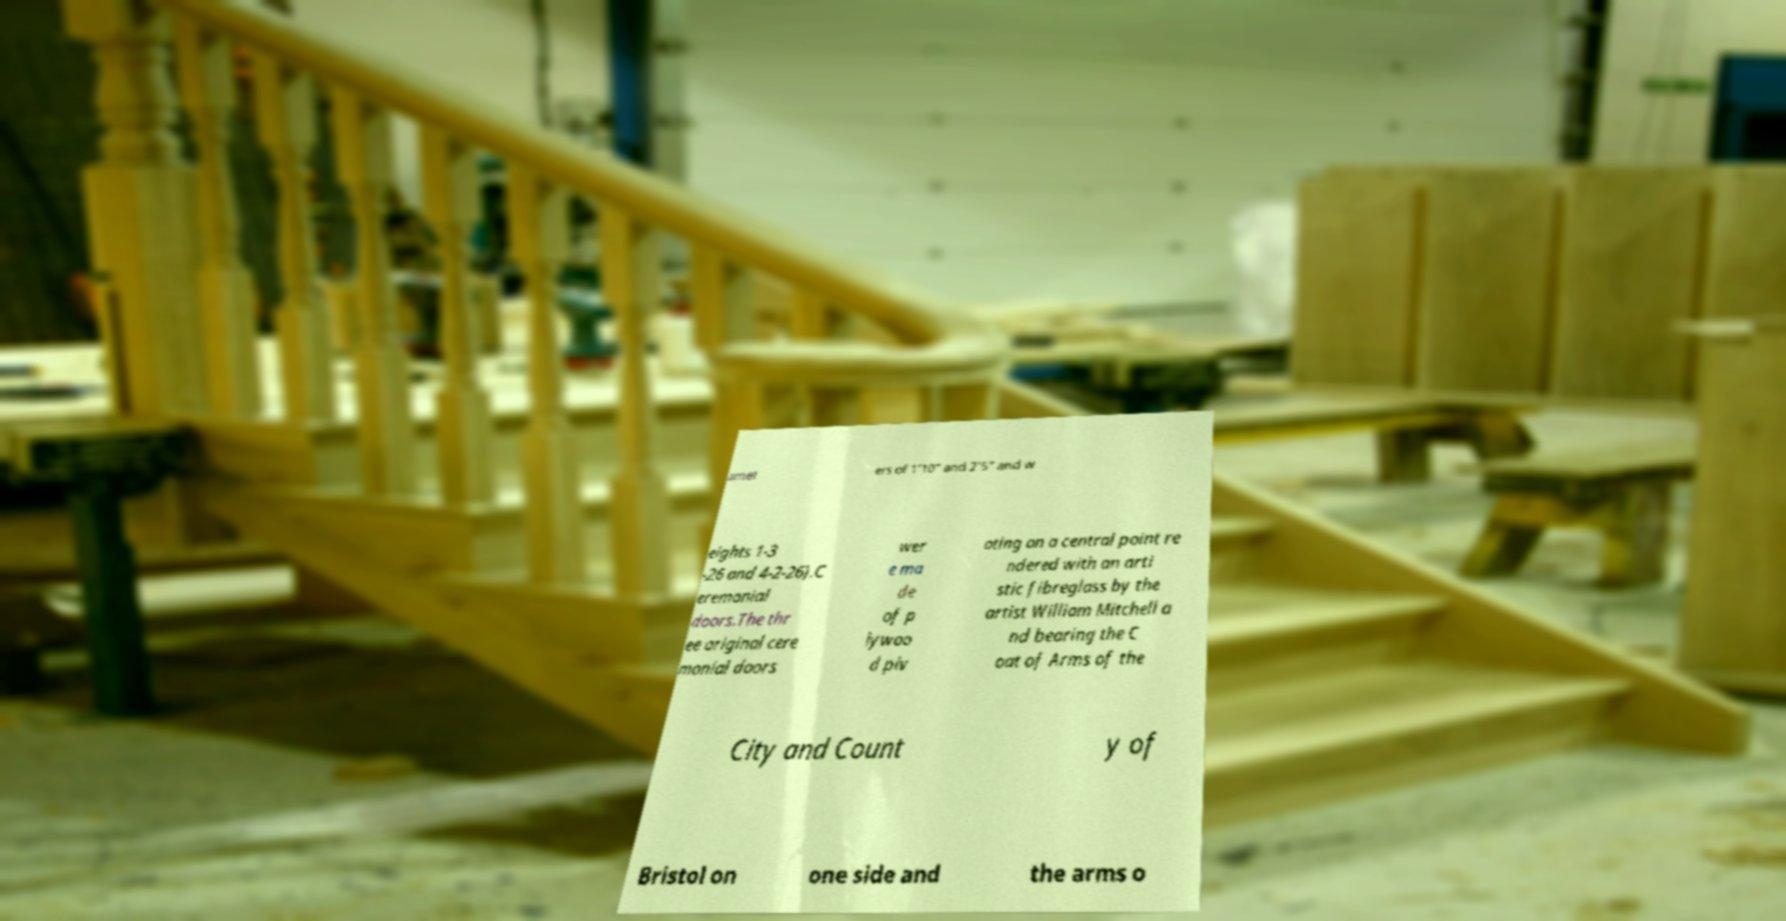Please identify and transcribe the text found in this image. amet ers of 1’10” and 2’5” and w eights 1-3 -26 and 4-2-26).C eremonial doors.The thr ee original cere monial doors wer e ma de of p lywoo d piv oting on a central point re ndered with an arti stic fibreglass by the artist William Mitchell a nd bearing the C oat of Arms of the City and Count y of Bristol on one side and the arms o 